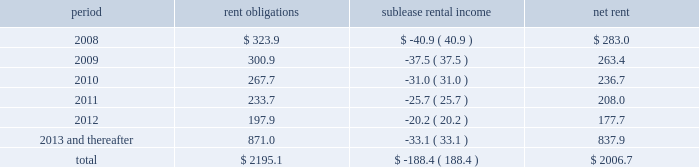Future minimum lease commitments for office premises and equipment under non-cancelable leases , along with minimum sublease rental income to be received under non-cancelable subleases , are as follows : period rent obligations sublease rental income net rent .
Guarantees we have certain contingent obligations under guarantees of certain of our subsidiaries ( 201cparent company guarantees 201d ) relating principally to credit facilities , guarantees of certain media payables and operating leases .
The amount of such parent company guarantees was $ 327.1 and $ 327.9 as of december 31 , 2007 and 2006 , respectively .
In the event of non-payment by the applicable subsidiary of the obligations covered by a guarantee , we would be obligated to pay the amounts covered by that guarantee .
As of december 31 , 2007 , there are no material assets pledged as security for such parent company guarantees .
Contingent acquisition obligations we have structured certain acquisitions with additional contingent purchase price obligations in order to reduce the potential risk associated with negative future performance of the acquired entity .
In addition , we have entered into agreements that may require us to purchase additional equity interests in certain consolidated and unconsolidated subsidiaries .
The amounts relating to these transactions are based on estimates of the future financial performance of the acquired entity , the timing of the exercise of these rights , changes in foreign currency exchange rates and other factors .
We have not recorded a liability for these items since the definitive amounts payable are not determinable or distributable .
When the contingent acquisition obligations have been met and consideration is determinable and distributable , we record the fair value of this consideration as an additional cost of the acquired entity .
However , we recognize deferred payments and purchases of additional interests after the effective date of purchase that are contingent upon the future employment of owners as compensation expense .
Compensation expense is determined based on the terms and conditions of the respective acquisition agreements and employment terms of the former owners of the acquired businesses .
This future expense will not be allocated to the assets and liabilities acquired and is amortized over the required employment terms of the former owners .
The following table details the estimated liability with respect to our contingent acquisition obligations and the estimated amount that would be paid under the options , in the event of exercise at the earliest exercise date .
All payments are contingent upon achieving projected operating performance targets and satisfying other notes to consolidated financial statements 2014 ( continued ) ( amounts in millions , except per share amounts ) .
What portion of the rent obligations will be paid-off through sublease rental income for 2008? 
Computations: (40.9 / 323.9)
Answer: 0.12627. Future minimum lease commitments for office premises and equipment under non-cancelable leases , along with minimum sublease rental income to be received under non-cancelable subleases , are as follows : period rent obligations sublease rental income net rent .
Guarantees we have certain contingent obligations under guarantees of certain of our subsidiaries ( 201cparent company guarantees 201d ) relating principally to credit facilities , guarantees of certain media payables and operating leases .
The amount of such parent company guarantees was $ 327.1 and $ 327.9 as of december 31 , 2007 and 2006 , respectively .
In the event of non-payment by the applicable subsidiary of the obligations covered by a guarantee , we would be obligated to pay the amounts covered by that guarantee .
As of december 31 , 2007 , there are no material assets pledged as security for such parent company guarantees .
Contingent acquisition obligations we have structured certain acquisitions with additional contingent purchase price obligations in order to reduce the potential risk associated with negative future performance of the acquired entity .
In addition , we have entered into agreements that may require us to purchase additional equity interests in certain consolidated and unconsolidated subsidiaries .
The amounts relating to these transactions are based on estimates of the future financial performance of the acquired entity , the timing of the exercise of these rights , changes in foreign currency exchange rates and other factors .
We have not recorded a liability for these items since the definitive amounts payable are not determinable or distributable .
When the contingent acquisition obligations have been met and consideration is determinable and distributable , we record the fair value of this consideration as an additional cost of the acquired entity .
However , we recognize deferred payments and purchases of additional interests after the effective date of purchase that are contingent upon the future employment of owners as compensation expense .
Compensation expense is determined based on the terms and conditions of the respective acquisition agreements and employment terms of the former owners of the acquired businesses .
This future expense will not be allocated to the assets and liabilities acquired and is amortized over the required employment terms of the former owners .
The following table details the estimated liability with respect to our contingent acquisition obligations and the estimated amount that would be paid under the options , in the event of exercise at the earliest exercise date .
All payments are contingent upon achieving projected operating performance targets and satisfying other notes to consolidated financial statements 2014 ( continued ) ( amounts in millions , except per share amounts ) .
What is the average of parent company guarantees from 2006-2007? 
Computations: ((327.1 + 327.9) / 2)
Answer: 327.5. 